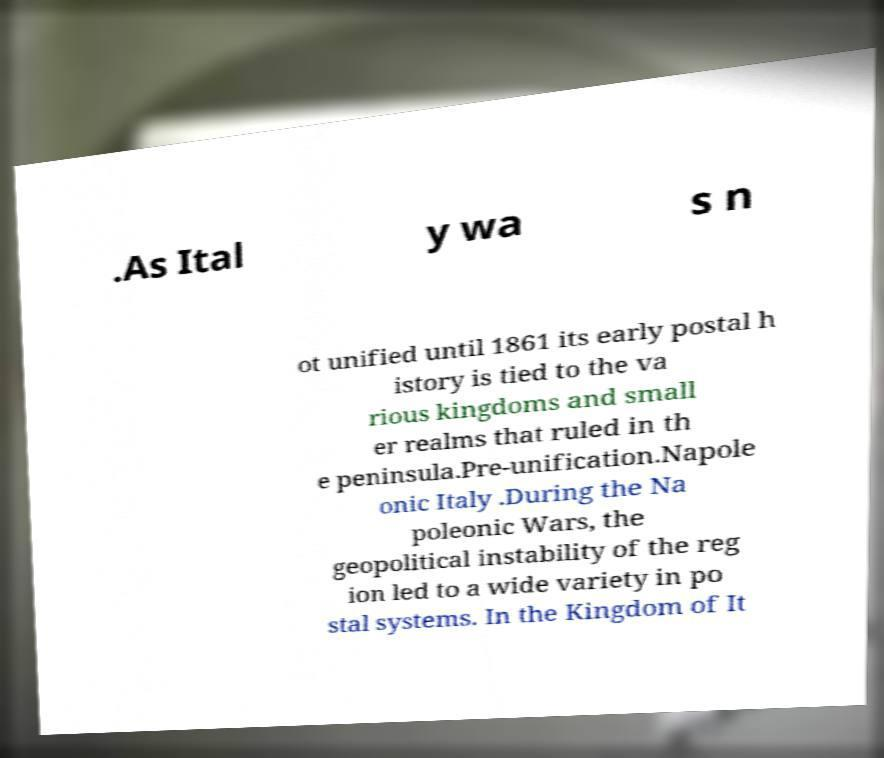There's text embedded in this image that I need extracted. Can you transcribe it verbatim? .As Ital y wa s n ot unified until 1861 its early postal h istory is tied to the va rious kingdoms and small er realms that ruled in th e peninsula.Pre-unification.Napole onic Italy .During the Na poleonic Wars, the geopolitical instability of the reg ion led to a wide variety in po stal systems. In the Kingdom of It 